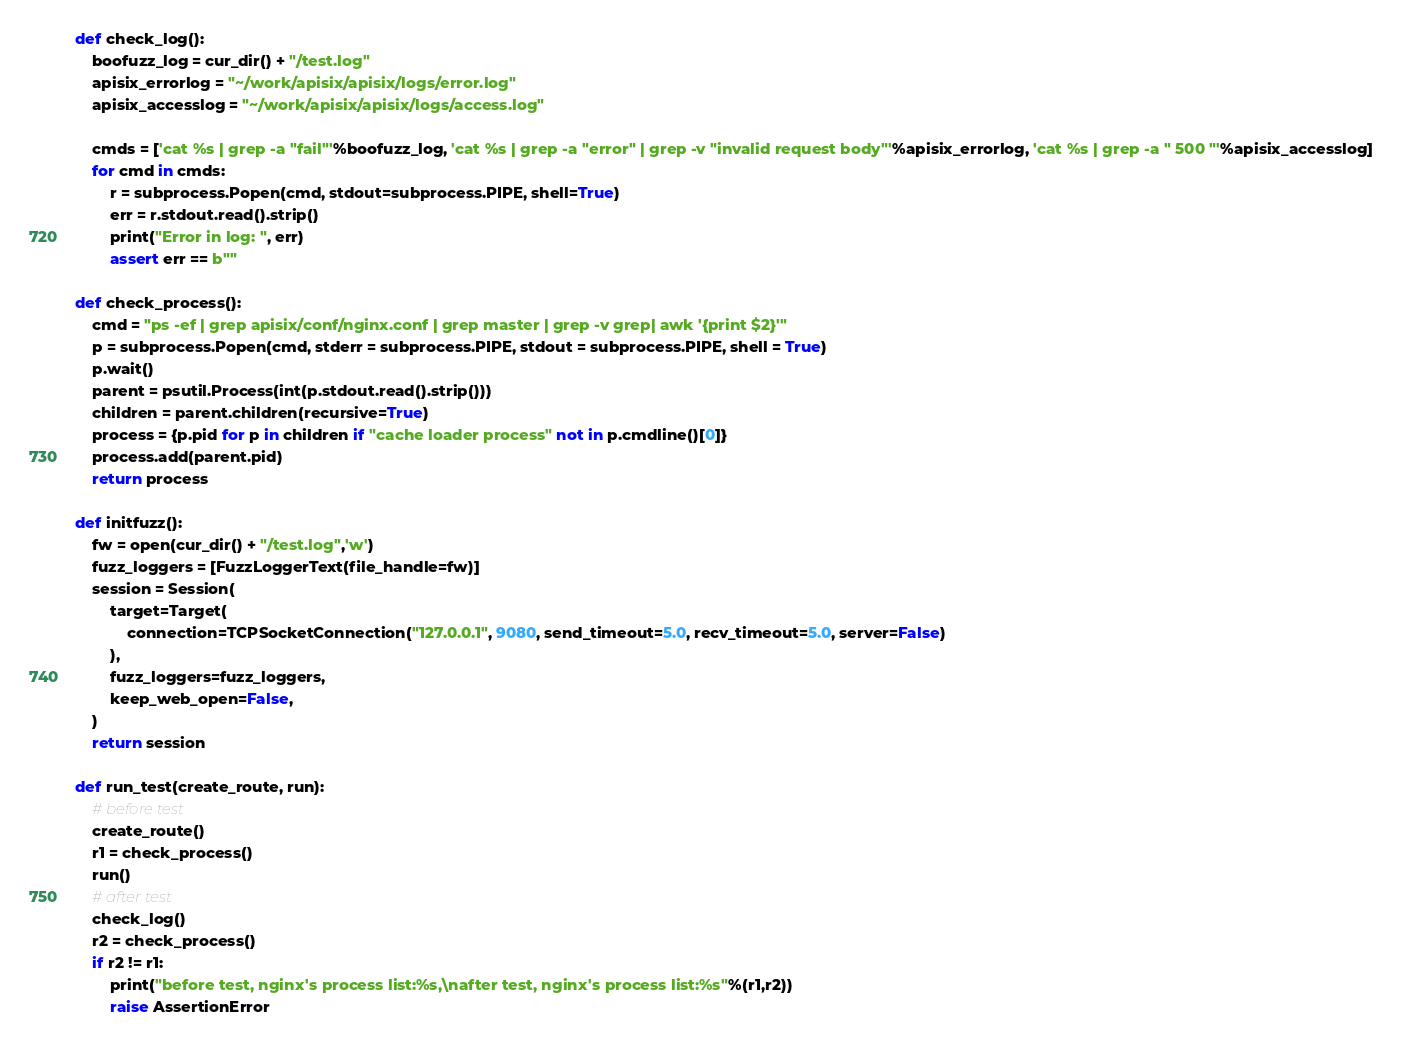<code> <loc_0><loc_0><loc_500><loc_500><_Python_>def check_log():
    boofuzz_log = cur_dir() + "/test.log"
    apisix_errorlog = "~/work/apisix/apisix/logs/error.log"
    apisix_accesslog = "~/work/apisix/apisix/logs/access.log"

    cmds = ['cat %s | grep -a "fail"'%boofuzz_log, 'cat %s | grep -a "error" | grep -v "invalid request body"'%apisix_errorlog, 'cat %s | grep -a " 500 "'%apisix_accesslog]
    for cmd in cmds:
        r = subprocess.Popen(cmd, stdout=subprocess.PIPE, shell=True)
        err = r.stdout.read().strip()
        print("Error in log: ", err)
        assert err == b""

def check_process():
    cmd = "ps -ef | grep apisix/conf/nginx.conf | grep master | grep -v grep| awk '{print $2}'"
    p = subprocess.Popen(cmd, stderr = subprocess.PIPE, stdout = subprocess.PIPE, shell = True)
    p.wait()
    parent = psutil.Process(int(p.stdout.read().strip()))
    children = parent.children(recursive=True)
    process = {p.pid for p in children if "cache loader process" not in p.cmdline()[0]}
    process.add(parent.pid)
    return process

def initfuzz():
    fw = open(cur_dir() + "/test.log",'w')
    fuzz_loggers = [FuzzLoggerText(file_handle=fw)]
    session = Session(
        target=Target(
            connection=TCPSocketConnection("127.0.0.1", 9080, send_timeout=5.0, recv_timeout=5.0, server=False)
        ),
        fuzz_loggers=fuzz_loggers,
        keep_web_open=False,
    )
    return session

def run_test(create_route, run):
    # before test
    create_route()
    r1 = check_process()
    run()
    # after test
    check_log()
    r2 = check_process()
    if r2 != r1:
        print("before test, nginx's process list:%s,\nafter test, nginx's process list:%s"%(r1,r2))
        raise AssertionError
</code> 